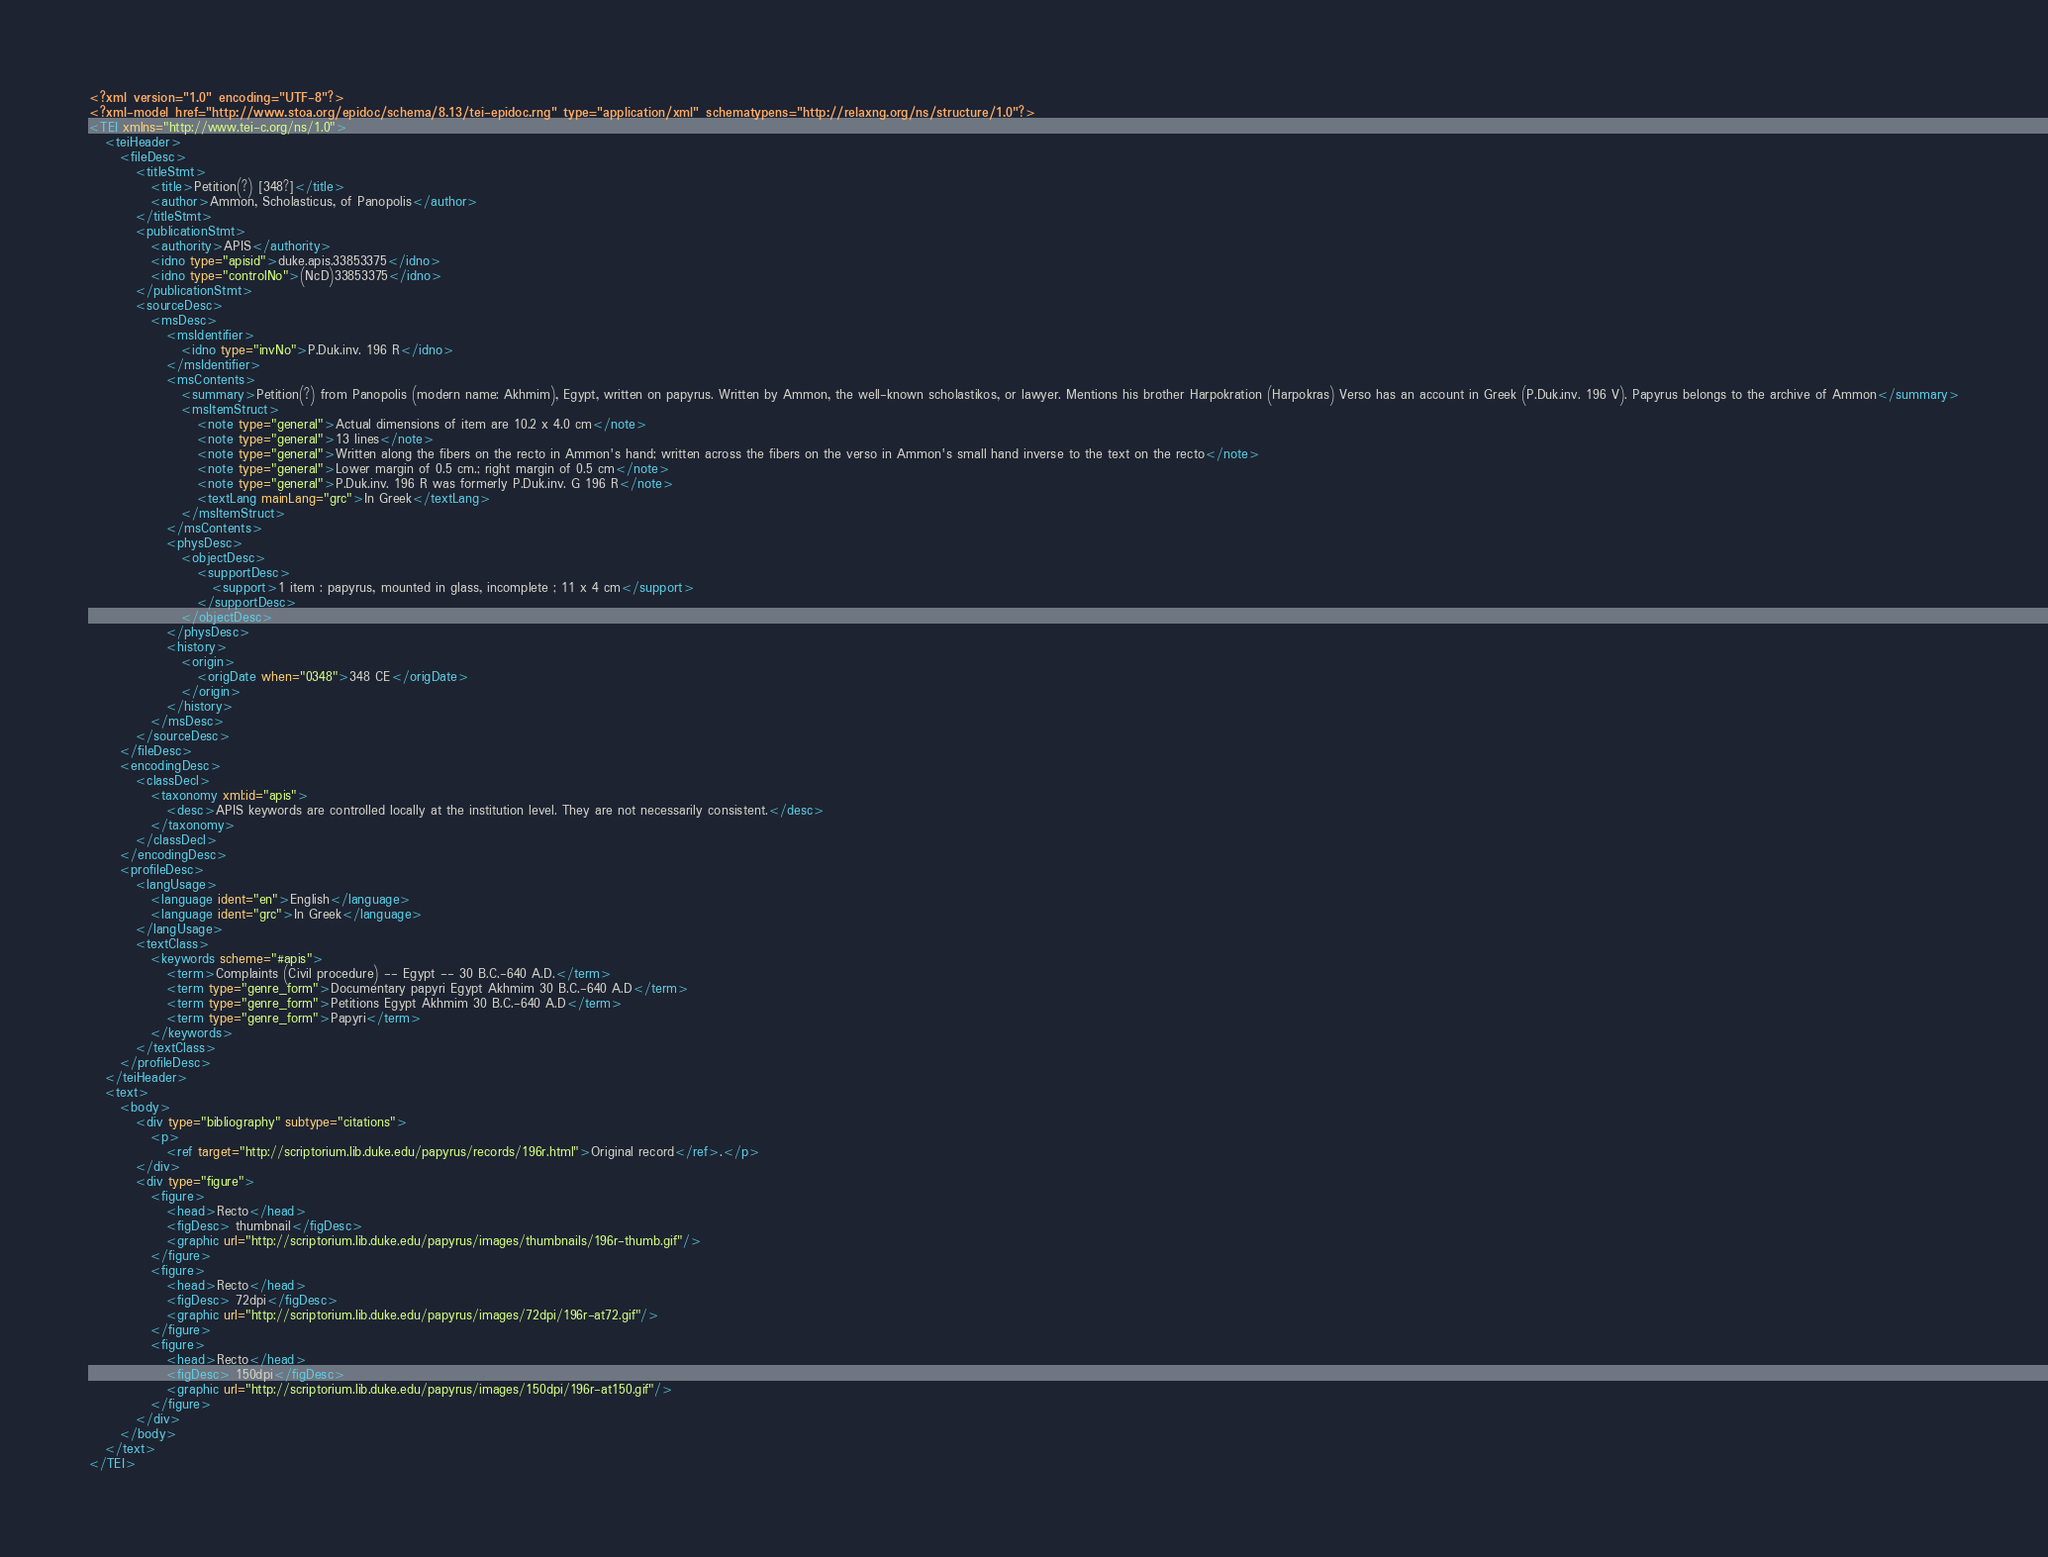<code> <loc_0><loc_0><loc_500><loc_500><_XML_><?xml version="1.0" encoding="UTF-8"?>
<?xml-model href="http://www.stoa.org/epidoc/schema/8.13/tei-epidoc.rng" type="application/xml" schematypens="http://relaxng.org/ns/structure/1.0"?>
<TEI xmlns="http://www.tei-c.org/ns/1.0">
   <teiHeader>
      <fileDesc>
         <titleStmt>
            <title>Petition(?) [348?]</title>
            <author>Ammon, Scholasticus, of Panopolis</author>
         </titleStmt>
         <publicationStmt>
            <authority>APIS</authority>
            <idno type="apisid">duke.apis.33853375</idno>
            <idno type="controlNo">(NcD)33853375</idno>
         </publicationStmt>
         <sourceDesc>
            <msDesc>
               <msIdentifier>
                  <idno type="invNo">P.Duk.inv. 196 R</idno>
               </msIdentifier>
               <msContents>
                  <summary>Petition(?) from Panopolis (modern name: Akhmim), Egypt, written on papyrus. Written by Ammon, the well-known scholastikos, or lawyer. Mentions his brother Harpokration (Harpokras) Verso has an account in Greek (P.Duk.inv. 196 V). Papyrus belongs to the archive of Ammon</summary>
                  <msItemStruct>
                     <note type="general">Actual dimensions of item are 10.2 x 4.0 cm</note>
                     <note type="general">13 lines</note>
                     <note type="general">Written along the fibers on the recto in Ammon's hand; written across the fibers on the verso in Ammon's small hand inverse to the text on the recto</note>
                     <note type="general">Lower margin of 0.5 cm.; right margin of 0.5 cm</note>
                     <note type="general">P.Duk.inv. 196 R was formerly P.Duk.inv. G 196 R</note>
                     <textLang mainLang="grc">In Greek</textLang>
                  </msItemStruct>
               </msContents>
               <physDesc>
                  <objectDesc>
                     <supportDesc>
                        <support>1 item : papyrus, mounted in glass, incomplete ; 11 x 4 cm</support>
                     </supportDesc>
                  </objectDesc>
               </physDesc>
               <history>
                  <origin>
                     <origDate when="0348">348 CE</origDate>
                  </origin>
               </history>
            </msDesc>
         </sourceDesc>
      </fileDesc>
      <encodingDesc>
         <classDecl>
            <taxonomy xml:id="apis">
               <desc>APIS keywords are controlled locally at the institution level. They are not necessarily consistent.</desc>
            </taxonomy>
         </classDecl>
      </encodingDesc>
      <profileDesc>
         <langUsage>
            <language ident="en">English</language>
            <language ident="grc">In Greek</language>
         </langUsage>
         <textClass>
            <keywords scheme="#apis">
               <term>Complaints (Civil procedure) -- Egypt -- 30 B.C.-640 A.D.</term>
               <term type="genre_form">Documentary papyri Egypt Akhmim 30 B.C.-640 A.D</term>
               <term type="genre_form">Petitions Egypt Akhmim 30 B.C.-640 A.D</term>
               <term type="genre_form">Papyri</term>
            </keywords>
         </textClass>
      </profileDesc>
   </teiHeader>
   <text>
      <body>
         <div type="bibliography" subtype="citations">
            <p>
               <ref target="http://scriptorium.lib.duke.edu/papyrus/records/196r.html">Original record</ref>.</p>
         </div>
         <div type="figure">
            <figure>
               <head>Recto</head>
               <figDesc> thumbnail</figDesc>
               <graphic url="http://scriptorium.lib.duke.edu/papyrus/images/thumbnails/196r-thumb.gif"/>
            </figure>
            <figure>
               <head>Recto</head>
               <figDesc> 72dpi</figDesc>
               <graphic url="http://scriptorium.lib.duke.edu/papyrus/images/72dpi/196r-at72.gif"/>
            </figure>
            <figure>
               <head>Recto</head>
               <figDesc> 150dpi</figDesc>
               <graphic url="http://scriptorium.lib.duke.edu/papyrus/images/150dpi/196r-at150.gif"/>
            </figure>
         </div>
      </body>
   </text>
</TEI>
</code> 